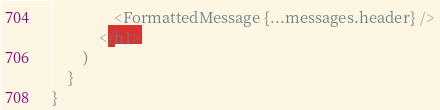<code> <loc_0><loc_0><loc_500><loc_500><_JavaScript_>				<FormattedMessage {...messages.header} />
			</h1>
		)
	}
}
</code> 